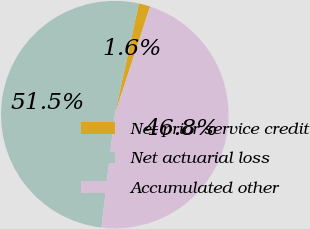Convert chart to OTSL. <chart><loc_0><loc_0><loc_500><loc_500><pie_chart><fcel>Net prior service credit<fcel>Net actuarial loss<fcel>Accumulated other<nl><fcel>1.62%<fcel>51.53%<fcel>46.85%<nl></chart> 